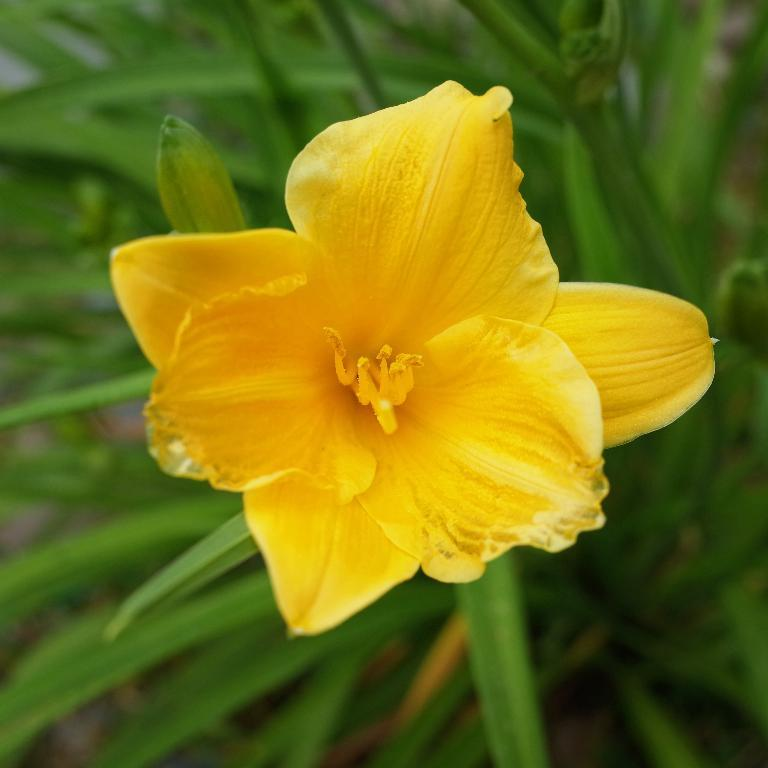What type of flower is in the image? There is a yellow flower in the image. Where is the flower located in relation to the image? The flower is in the front of the image. What other plant elements can be seen in the image? There are green leaves in the background of the image. How would you describe the overall clarity of the image? The image is slightly blurry. How many pizzas are stacked on top of the needle in the image? There are no pizzas or needles present in the image; it features a yellow flower and green leaves. 